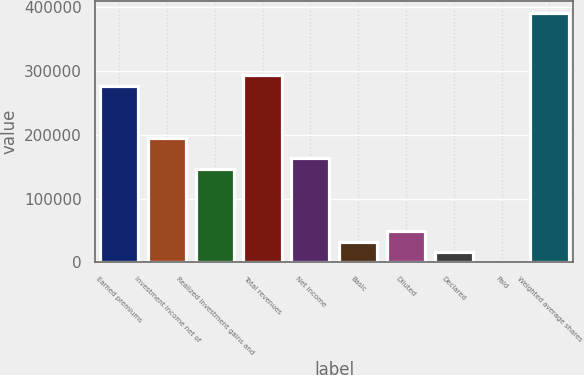Convert chart to OTSL. <chart><loc_0><loc_0><loc_500><loc_500><bar_chart><fcel>Earned premiums<fcel>Investment income net of<fcel>Realized investment gains and<fcel>Total revenues<fcel>Net income<fcel>Basic<fcel>Diluted<fcel>Declared<fcel>Paid<fcel>Weighted average shares<nl><fcel>276873<fcel>195440<fcel>146580<fcel>293159<fcel>162867<fcel>32574.6<fcel>48861.2<fcel>16288.1<fcel>1.56<fcel>390879<nl></chart> 